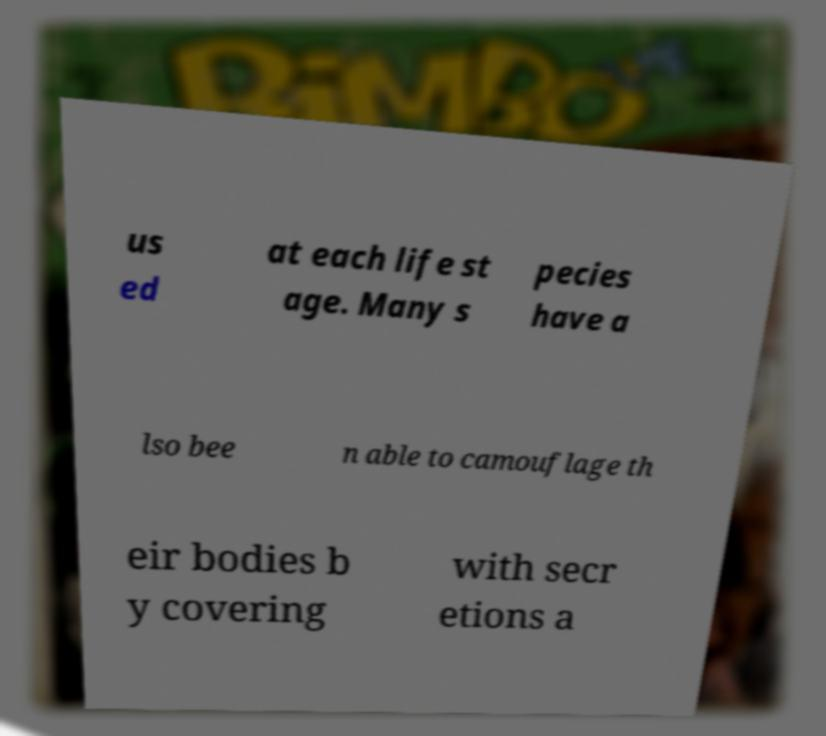Please read and relay the text visible in this image. What does it say? us ed at each life st age. Many s pecies have a lso bee n able to camouflage th eir bodies b y covering with secr etions a 